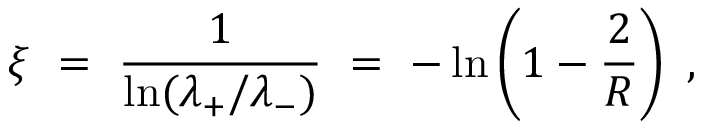<formula> <loc_0><loc_0><loc_500><loc_500>\xi \ = \ \frac { 1 } { \ln ( \lambda _ { + } / \lambda _ { - } ) } \ = \ - \ln \left ( 1 - \frac { 2 } { R } \right ) \ ,</formula> 